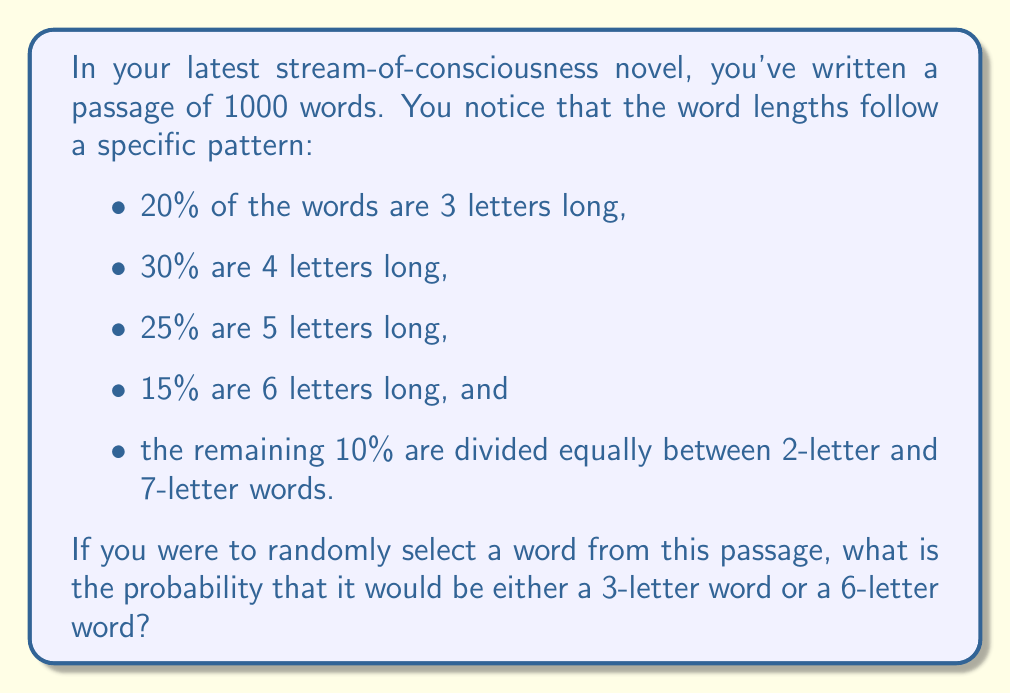Help me with this question. To solve this problem, we need to follow these steps:

1. Identify the probabilities of selecting a 3-letter word and a 6-letter word:
   - 3-letter words: 20% = 0.20
   - 6-letter words: 15% = 0.15

2. Calculate the probability of selecting either a 3-letter word OR a 6-letter word:
   - In probability theory, when we want the probability of either one event OR another (and these events are mutually exclusive), we add their individual probabilities.
   - Let $P(A)$ be the probability of selecting a 3-letter word and $P(B)$ be the probability of selecting a 6-letter word.
   - The probability we're looking for is $P(A \text{ or } B) = P(A) + P(B)$

3. Substitute the values and calculate:
   $$P(A \text{ or } B) = 0.20 + 0.15 = 0.35$$

Therefore, the probability of randomly selecting either a 3-letter word or a 6-letter word from your passage is 0.35 or 35%.

This calculation reflects the modernist technique of stream-of-consciousness writing, where the focus is often on the flow and rhythm of words rather than traditional sentence structures. The varying word lengths contribute to the unique cadence of the narrative, a characteristic often found in modernist literature.
Answer: 0.35 or 35% 